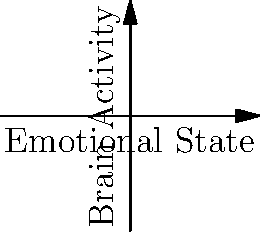Analyze the brain scan comparison graph showing brain activity relative to emotional state before and after reunion. What does the shift in the curve's shape and position indicate about the psychological impact of separation and reunion? To analyze the psychological impact of separation and reunion based on the brain scan comparison:

1. Observe the curves:
   - Blue curve (Before): Concave up, centered below the x-axis
   - Red curve (After): Concave down, centered above the x-axis

2. Interpret the x-axis (Emotional State):
   - Negative emotions on the left
   - Neutral emotions in the center
   - Positive emotions on the right

3. Interpret the y-axis (Brain Activity):
   - Higher values indicate increased brain activity

4. Compare the curves:
   a) At neutral emotional state (x = 0):
      - Before: Low brain activity (y ≈ -2)
      - After: High brain activity (y ≈ 2)
   b) Shape of curves:
      - Before: Increases rapidly for both positive and negative emotions
      - After: Decreases slightly for extreme emotions

5. Psychological implications:
   a) Increased overall brain activity after reunion
   b) More stable emotional responses after reunion
   c) Positive shift in baseline emotional state
   d) Reduced reactivity to extreme emotions after reunion

The shift in the curve indicates a significant positive change in emotional processing and regulation following the reunion, suggesting improved psychological well-being and resilience.
Answer: Positive shift in emotional baseline and improved emotional regulation post-reunion. 